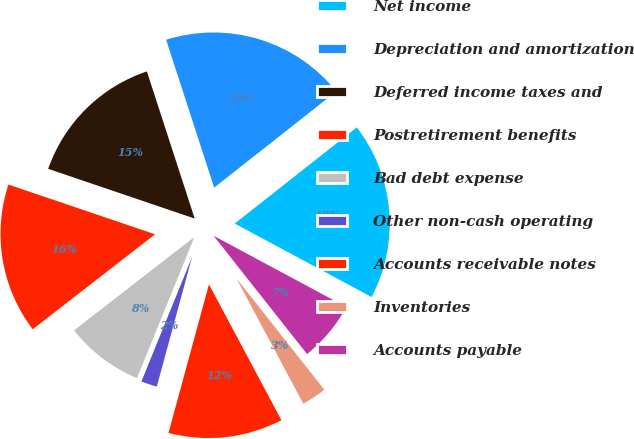Convert chart. <chart><loc_0><loc_0><loc_500><loc_500><pie_chart><fcel>Net income<fcel>Depreciation and amortization<fcel>Deferred income taxes and<fcel>Postretirement benefits<fcel>Bad debt expense<fcel>Other non-cash operating<fcel>Accounts receivable notes<fcel>Inventories<fcel>Accounts payable<nl><fcel>18.46%<fcel>19.38%<fcel>14.79%<fcel>15.71%<fcel>8.35%<fcel>1.92%<fcel>12.03%<fcel>2.84%<fcel>6.52%<nl></chart> 